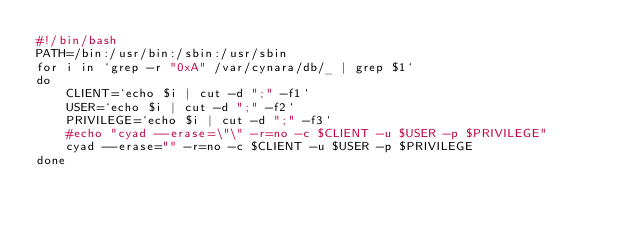Convert code to text. <code><loc_0><loc_0><loc_500><loc_500><_Bash_>#!/bin/bash
PATH=/bin:/usr/bin:/sbin:/usr/sbin
for i in `grep -r "0xA" /var/cynara/db/_ | grep $1`
do
    CLIENT=`echo $i | cut -d ";" -f1`
    USER=`echo $i | cut -d ";" -f2`
    PRIVILEGE=`echo $i | cut -d ";" -f3`
    #echo "cyad --erase=\"\" -r=no -c $CLIENT -u $USER -p $PRIVILEGE"
    cyad --erase="" -r=no -c $CLIENT -u $USER -p $PRIVILEGE
done
</code> 